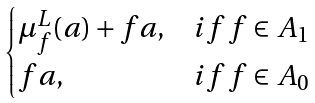Convert formula to latex. <formula><loc_0><loc_0><loc_500><loc_500>\begin{cases} \mu ^ { L } _ { f } ( a ) + f a , & i f \, f \in A _ { 1 } \\ f a , & i f \, f \in A _ { 0 } \end{cases}</formula> 